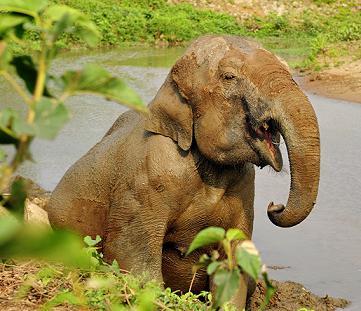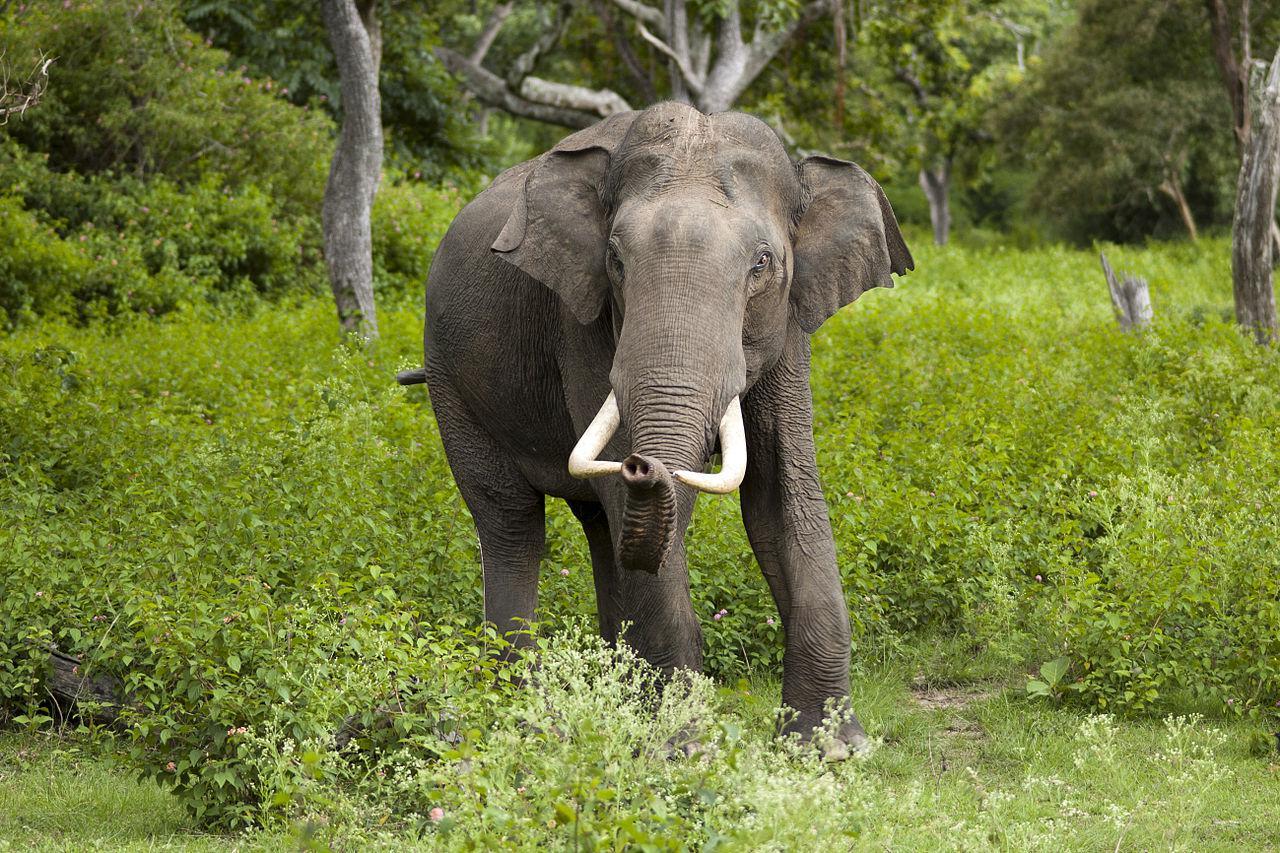The first image is the image on the left, the second image is the image on the right. Examine the images to the left and right. Is the description "An elephant with tusks has the end of his trunk curled and raised up." accurate? Answer yes or no. Yes. The first image is the image on the left, the second image is the image on the right. Assess this claim about the two images: "The elephant in the left image is near the water.". Correct or not? Answer yes or no. Yes. 